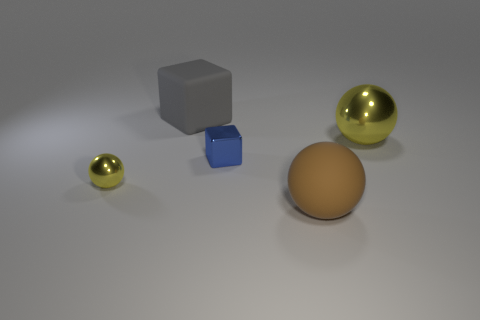Subtract all yellow metal spheres. How many spheres are left? 1 Add 1 big brown blocks. How many objects exist? 6 Subtract all yellow spheres. How many spheres are left? 1 Subtract all spheres. How many objects are left? 2 Subtract 1 cubes. How many cubes are left? 1 Subtract all gray cylinders. How many blue blocks are left? 1 Subtract all red metallic cubes. Subtract all big gray things. How many objects are left? 4 Add 5 small objects. How many small objects are left? 7 Add 4 tiny yellow things. How many tiny yellow things exist? 5 Subtract 0 brown cylinders. How many objects are left? 5 